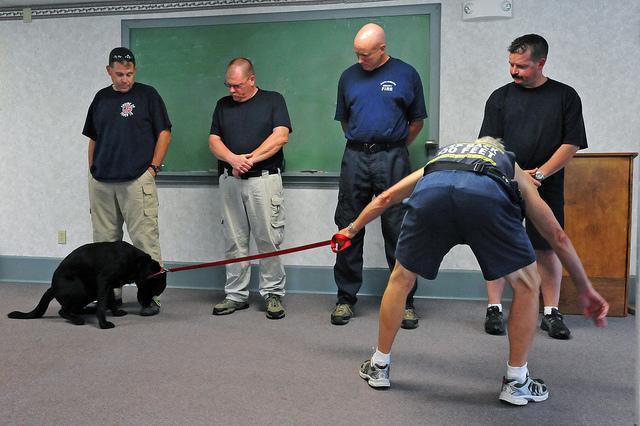How many people in shorts?
Give a very brief answer. 2. How many people are there?
Give a very brief answer. 5. 